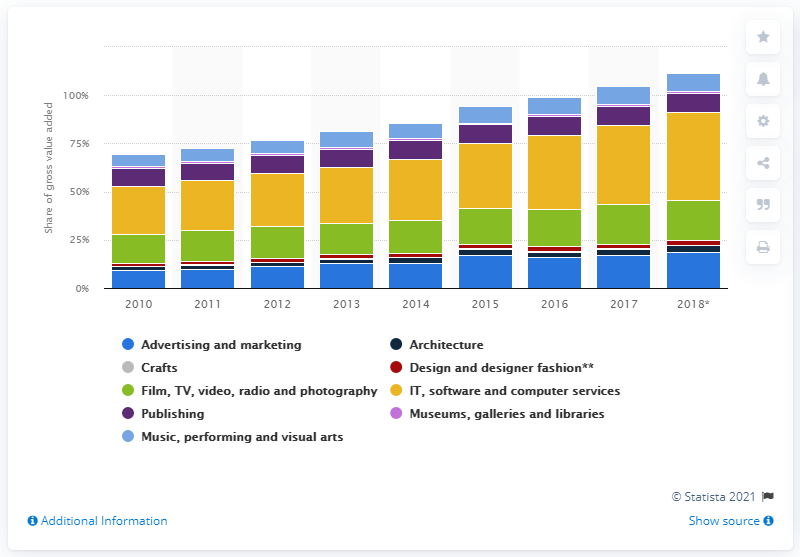Specify some key components in this picture. In 2018, IT, software and computer services accounted for 45.4% of the GVA (Gross Value Added) of all creative industries. 